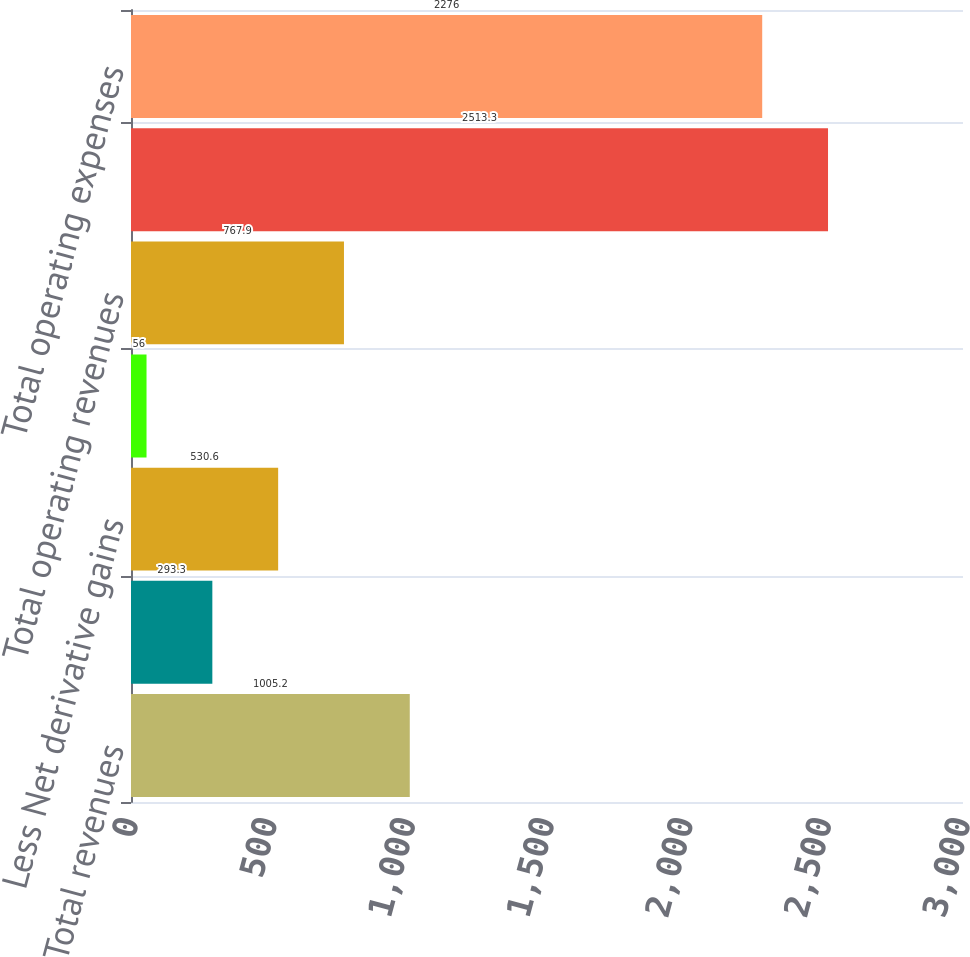Convert chart to OTSL. <chart><loc_0><loc_0><loc_500><loc_500><bar_chart><fcel>Total revenues<fcel>Less Net investment gains<fcel>Less Net derivative gains<fcel>Less Other adjustments to<fcel>Total operating revenues<fcel>Total expenses<fcel>Total operating expenses<nl><fcel>1005.2<fcel>293.3<fcel>530.6<fcel>56<fcel>767.9<fcel>2513.3<fcel>2276<nl></chart> 